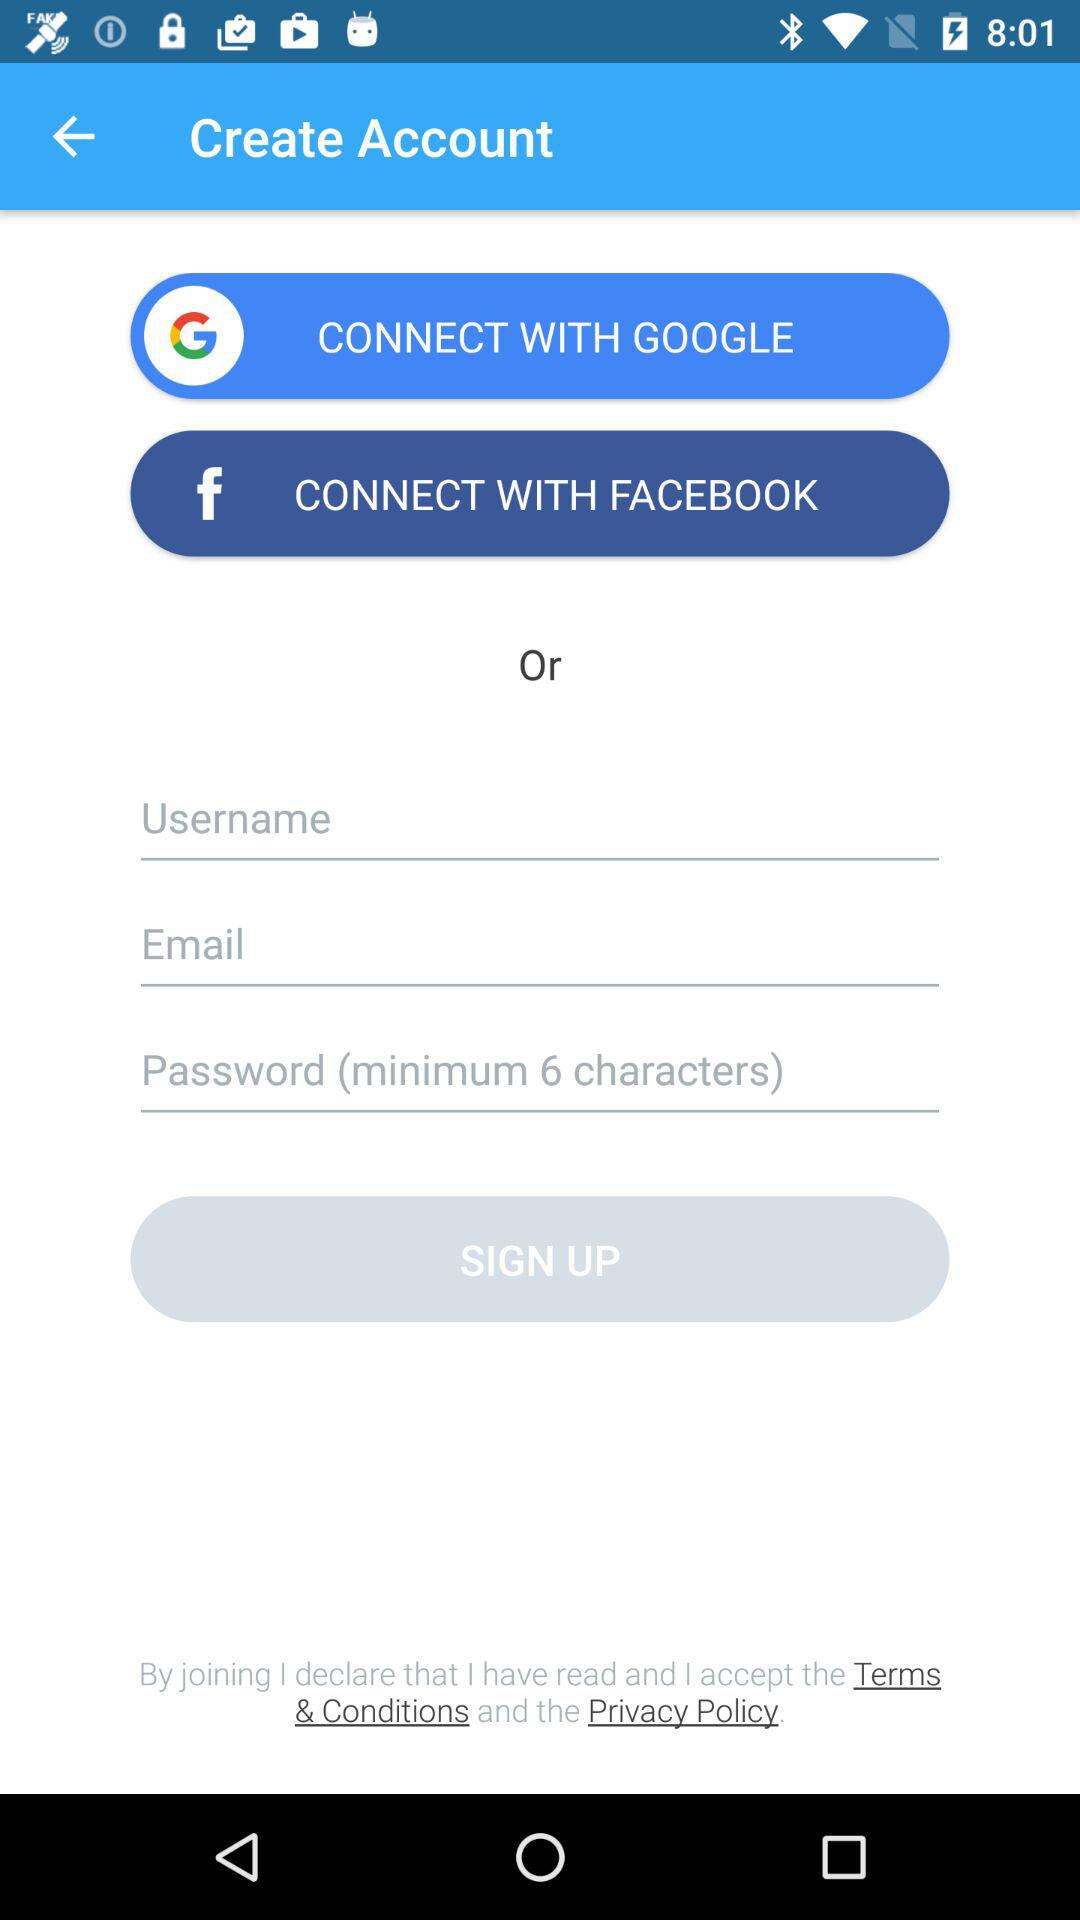How many fields are there on the sign up form?
Answer the question using a single word or phrase. 3 